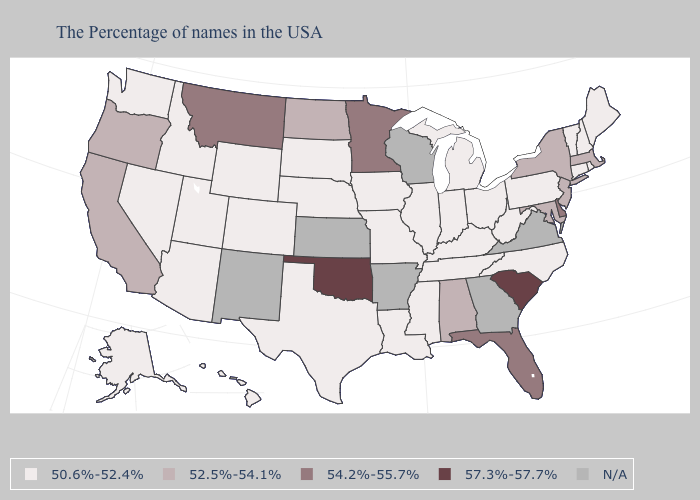What is the value of Pennsylvania?
Keep it brief. 50.6%-52.4%. Does the map have missing data?
Quick response, please. Yes. What is the value of Alaska?
Answer briefly. 50.6%-52.4%. Among the states that border Colorado , does Utah have the highest value?
Answer briefly. No. What is the value of Illinois?
Write a very short answer. 50.6%-52.4%. Does Minnesota have the highest value in the MidWest?
Concise answer only. Yes. What is the highest value in the USA?
Write a very short answer. 57.3%-57.7%. Which states have the highest value in the USA?
Keep it brief. South Carolina, Oklahoma. Which states have the highest value in the USA?
Concise answer only. South Carolina, Oklahoma. What is the highest value in the West ?
Concise answer only. 54.2%-55.7%. Does South Carolina have the lowest value in the USA?
Be succinct. No. Is the legend a continuous bar?
Answer briefly. No. Which states have the lowest value in the West?
Answer briefly. Wyoming, Colorado, Utah, Arizona, Idaho, Nevada, Washington, Alaska, Hawaii. Name the states that have a value in the range N/A?
Be succinct. Virginia, Georgia, Wisconsin, Arkansas, Kansas, New Mexico. 